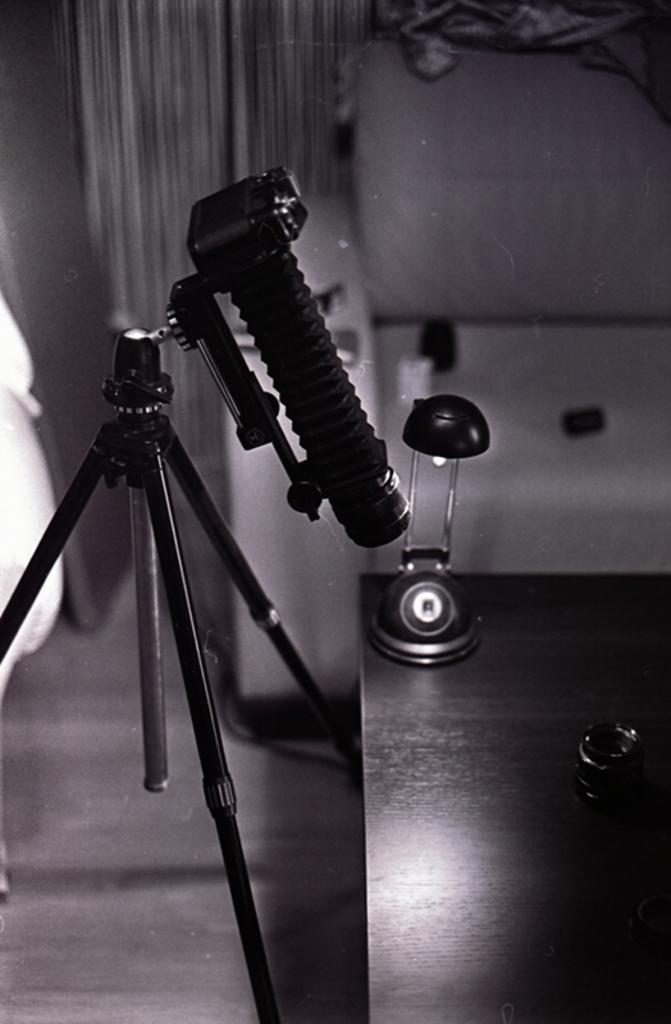Please provide a concise description of this image. This is black and white image where we can see a tripod stand and a camera. In the right bottom of the image, there is a table. On the table, we can see light and one object. In the background, there is a wall. 